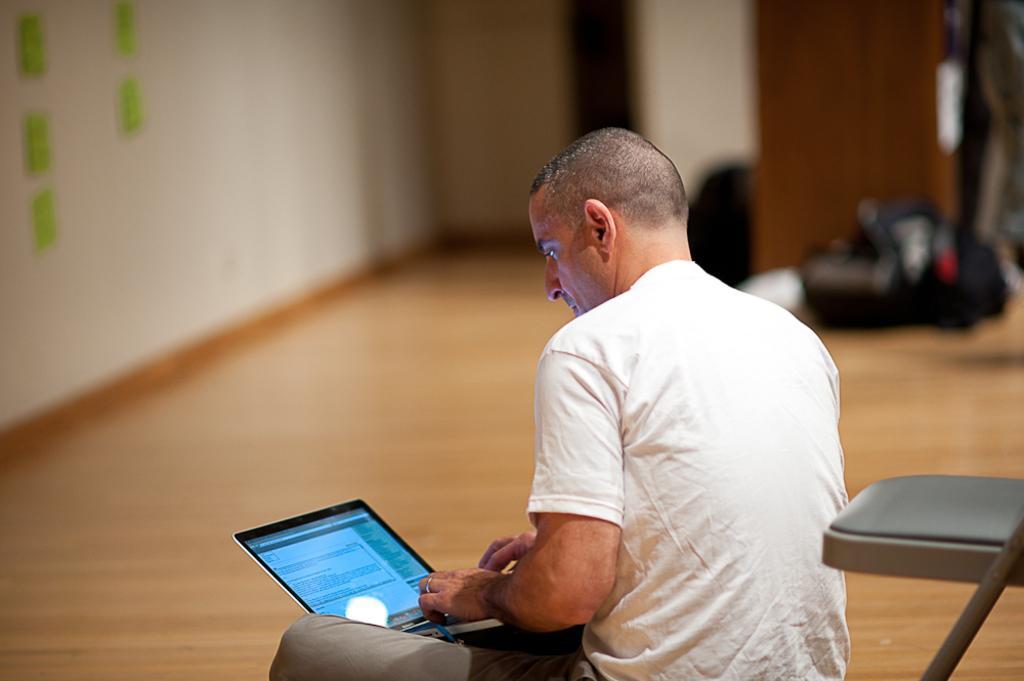Could you give a brief overview of what you see in this image? In the foreground I can see a person is sitting on the floor and holding a laptop in hand and a chair. In the background I can see a wall, bags and so on. This image is taken in a hall. 